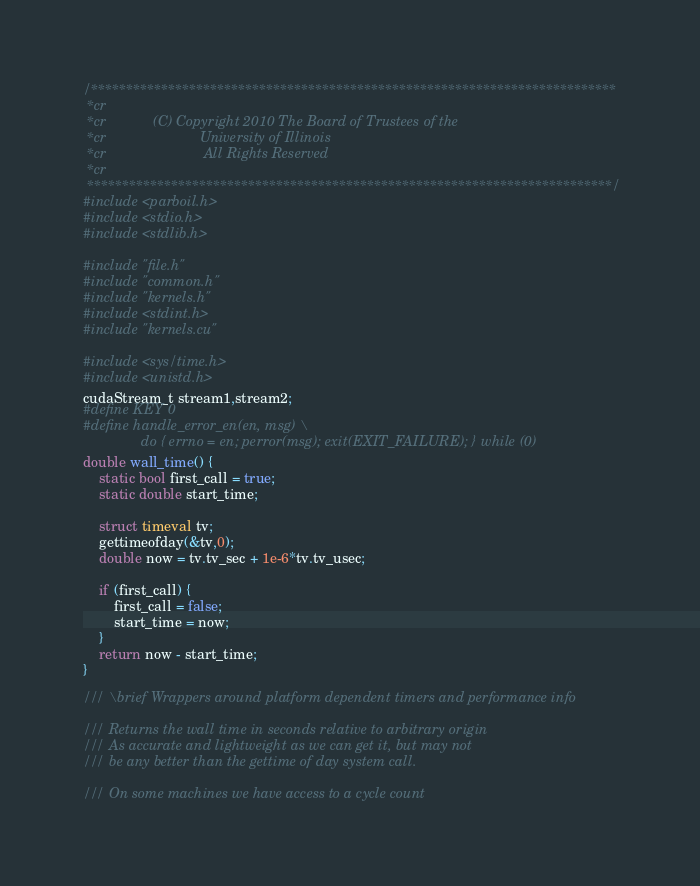<code> <loc_0><loc_0><loc_500><loc_500><_Cuda_>
/***************************************************************************
 *cr
 *cr            (C) Copyright 2010 The Board of Trustees of the
 *cr                        University of Illinois
 *cr                         All Rights Reserved
 *cr
 ***************************************************************************/
#include <parboil.h>
#include <stdio.h>
#include <stdlib.h>

#include "file.h"
#include "common.h"
#include "kernels.h"
#include <stdint.h>
#include "kernels.cu"

#include <sys/time.h>
#include <unistd.h>
cudaStream_t stream1,stream2;
#define KEY 0
#define handle_error_en(en, msg) \
               do { errno = en; perror(msg); exit(EXIT_FAILURE); } while (0)
double wall_time() {
	static bool first_call = true;
	static double start_time;

	struct timeval tv;
	gettimeofday(&tv,0);
	double now = tv.tv_sec + 1e-6*tv.tv_usec;

	if (first_call) {
		first_call = false;
		start_time = now;
	}
	return now - start_time;
}

/// \brief Wrappers around platform dependent timers and performance info

/// Returns the wall time in seconds relative to arbitrary origin
/// As accurate and lightweight as we can get it, but may not
/// be any better than the gettime of day system call.

/// On some machines we have access to a cycle count
</code> 